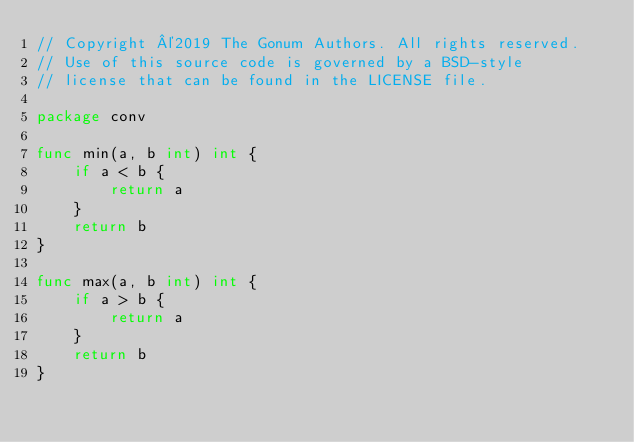<code> <loc_0><loc_0><loc_500><loc_500><_Go_>// Copyright ©2019 The Gonum Authors. All rights reserved.
// Use of this source code is governed by a BSD-style
// license that can be found in the LICENSE file.

package conv

func min(a, b int) int {
	if a < b {
		return a
	}
	return b
}

func max(a, b int) int {
	if a > b {
		return a
	}
	return b
}
</code> 